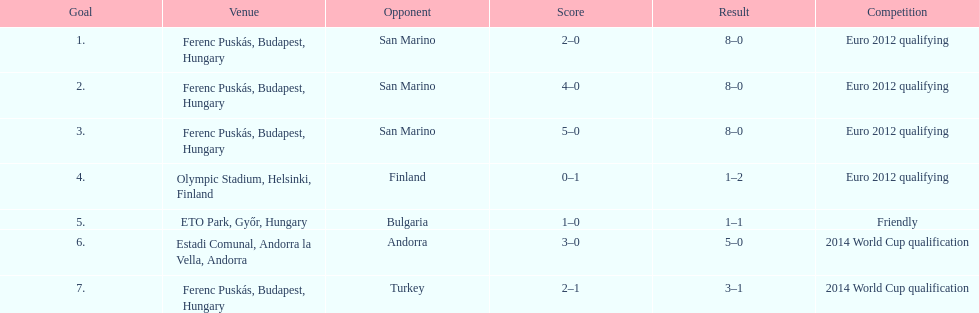What is the total number of international goals ádám szalai has made? 7. 